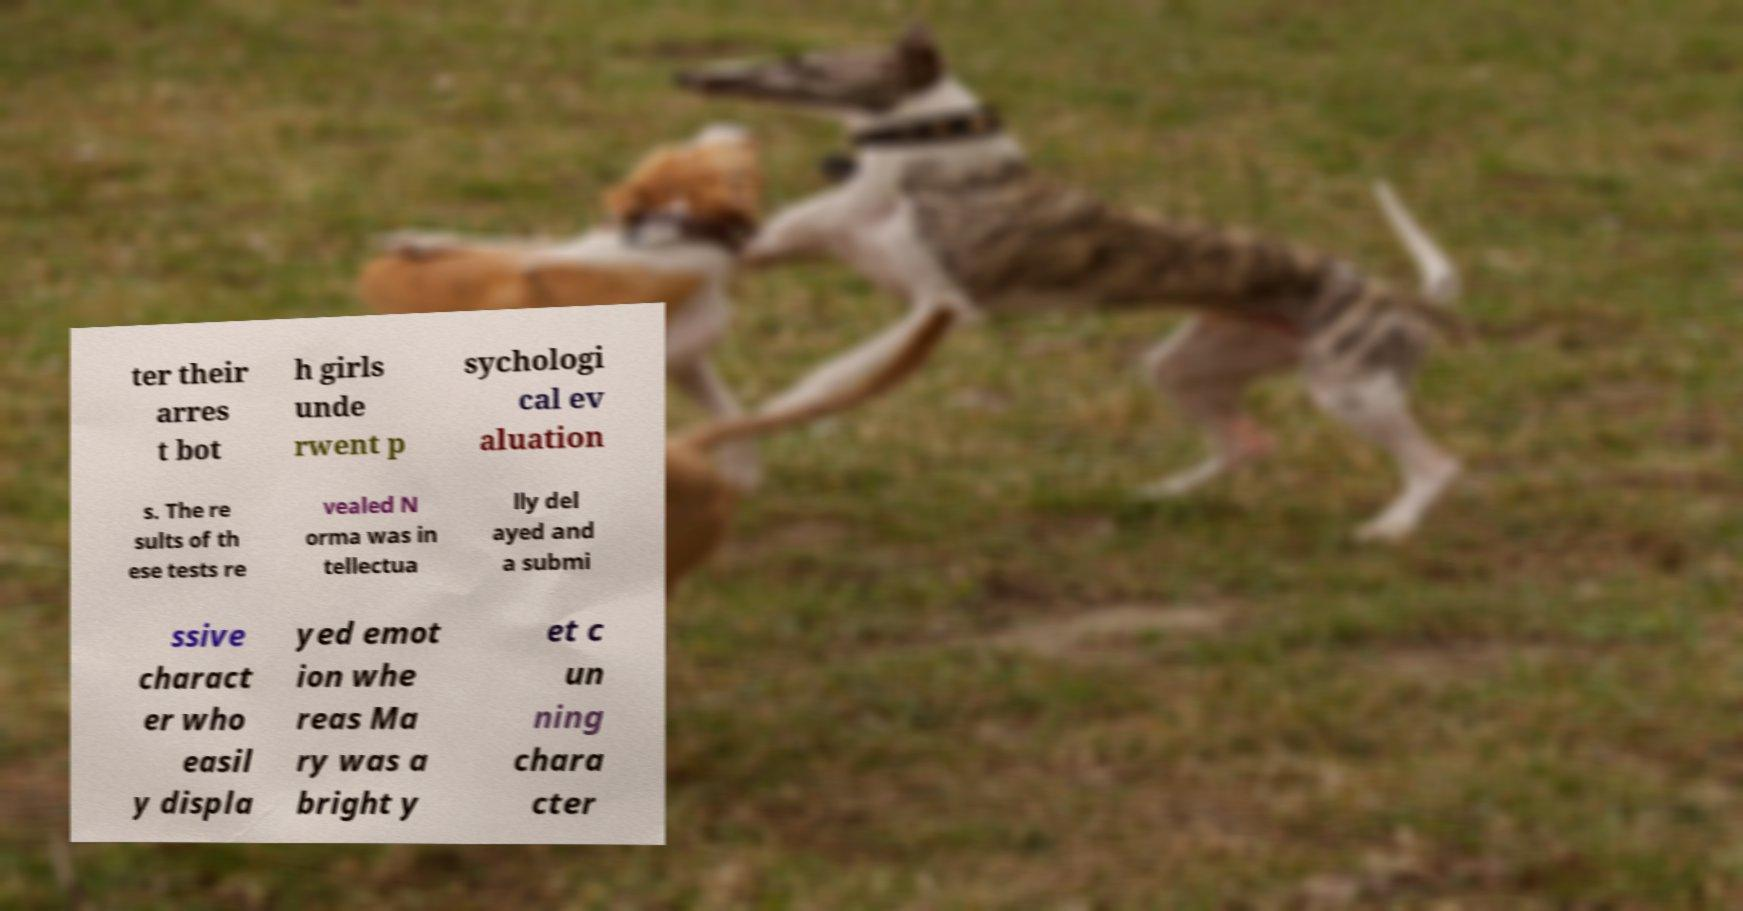I need the written content from this picture converted into text. Can you do that? ter their arres t bot h girls unde rwent p sychologi cal ev aluation s. The re sults of th ese tests re vealed N orma was in tellectua lly del ayed and a submi ssive charact er who easil y displa yed emot ion whe reas Ma ry was a bright y et c un ning chara cter 